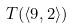Convert formula to latex. <formula><loc_0><loc_0><loc_500><loc_500>T ( \langle 9 , 2 \rangle )</formula> 